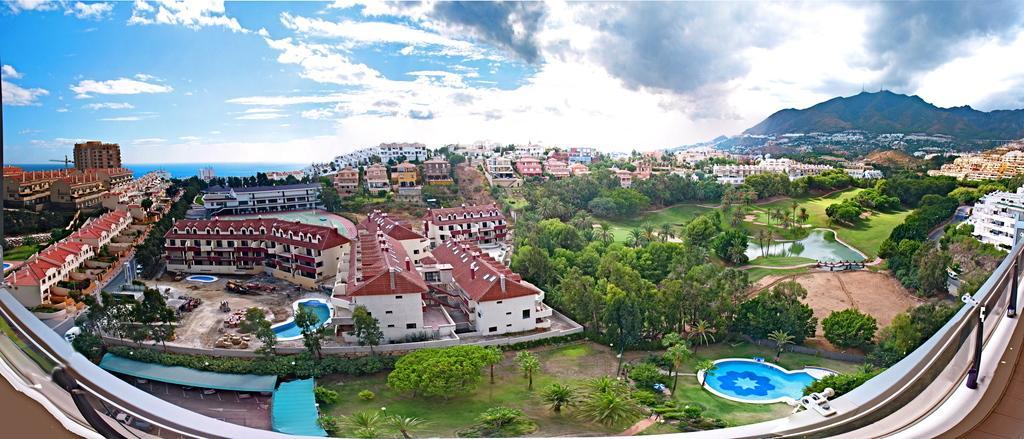Please provide a concise description of this image. In this image we can see a few buildings, there are some trees, plants, swimming pools, sheds, vehicles, grass and mountains, in the background, we can see the sky with clouds. 